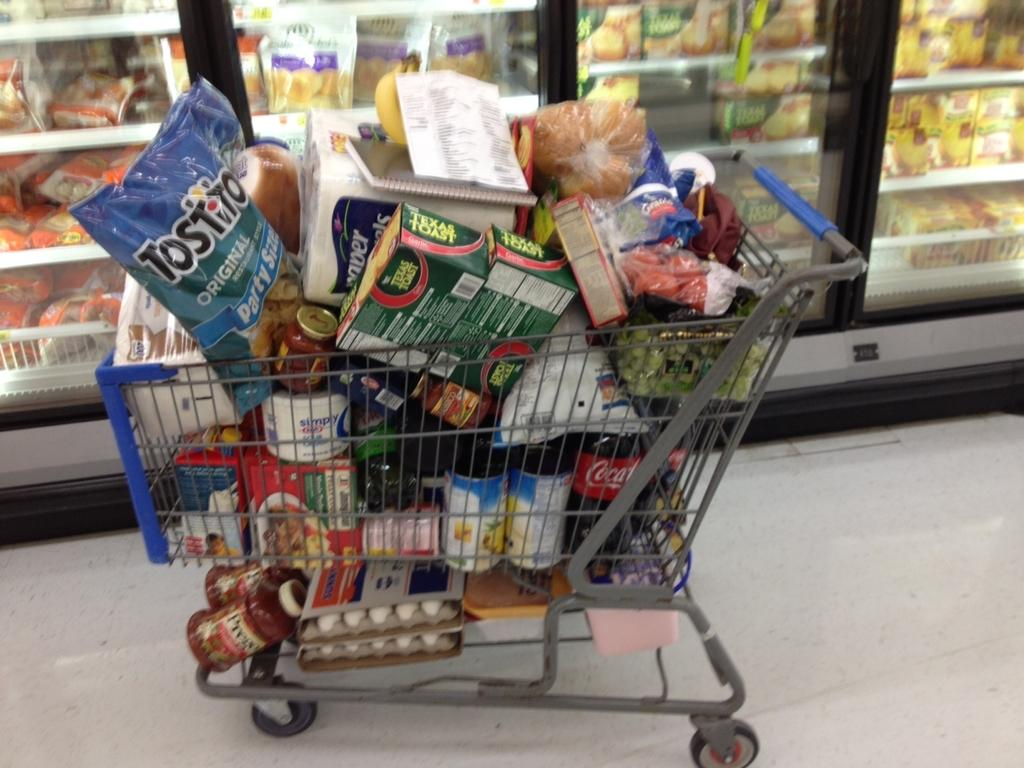<image>
Describe the image concisely. A full shopping trolley with a bag of original Tostito. 